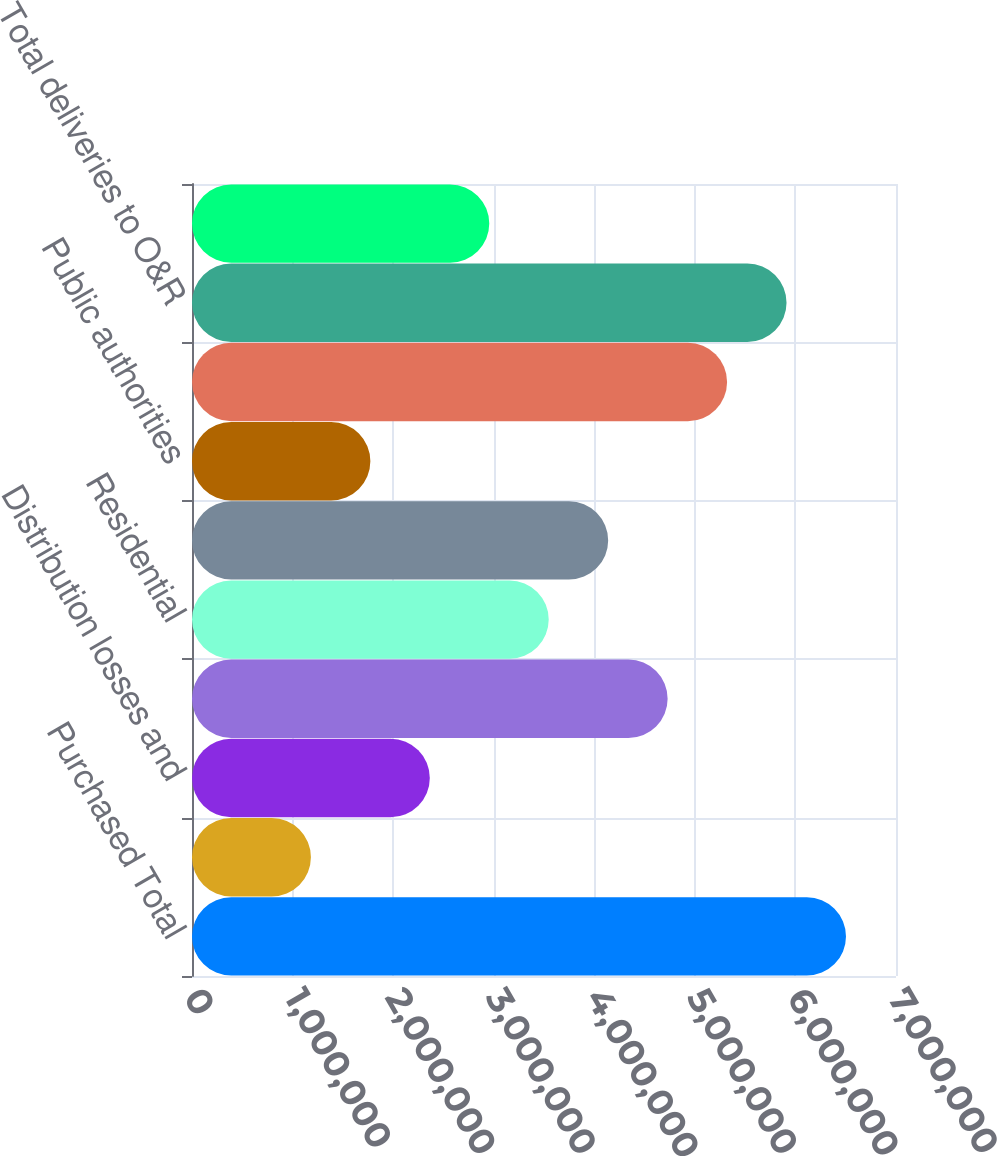Convert chart. <chart><loc_0><loc_0><loc_500><loc_500><bar_chart><fcel>Purchased Total<fcel>Less Used by company<fcel>Distribution losses and<fcel>Purchased Net<fcel>Residential<fcel>Commercial and industrial<fcel>Public authorities<fcel>Sold Energy Electric Total<fcel>Total deliveries to O&R<fcel>Delivery service for retail<nl><fcel>6.50273e+06<fcel>1.18233e+06<fcel>2.36464e+06<fcel>4.72926e+06<fcel>3.54695e+06<fcel>4.13811e+06<fcel>1.77348e+06<fcel>5.32042e+06<fcel>5.91158e+06<fcel>2.95579e+06<nl></chart> 